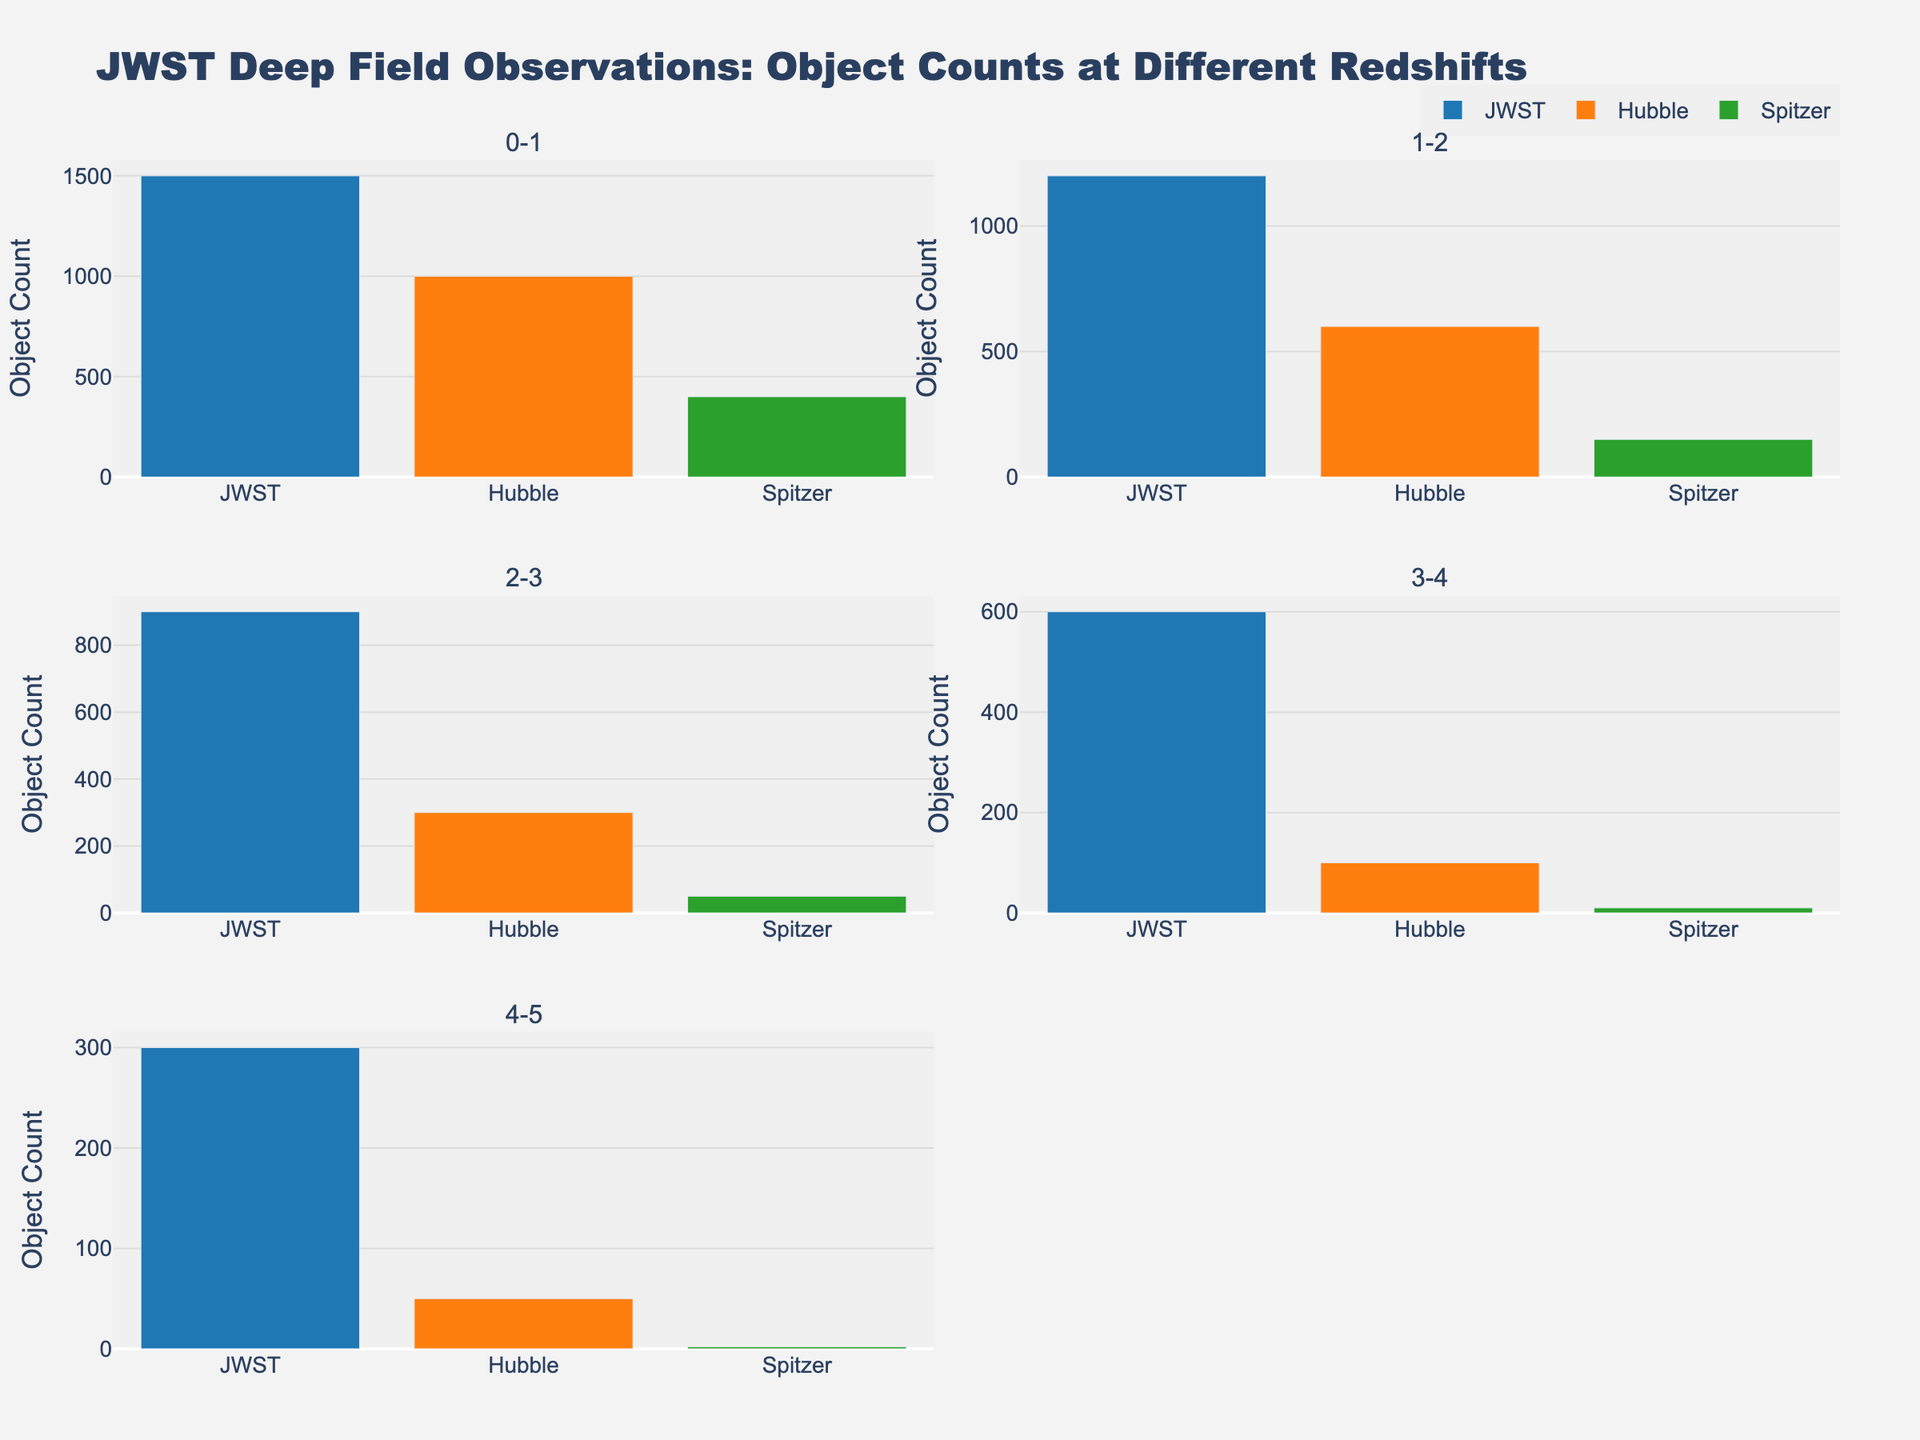What are the main telescopes compared in the subplots? The figure shows JWST, Hubble, and Spitzer as the primary telescopes compared in each subplot. These are indicated by the plot legends and color codes associated with each bar.
Answer: JWST, Hubble, Spitzer What is the title of the entire figure? The title of the figure is displayed at the top of the plot and reads "JWST Deep Field Observations: Object Counts at Different Redshifts".
Answer: JWST Deep Field Observations: Object Counts at Different Redshifts In the redshift range 1-2, how many objects did JWST observe? In the subplot for the redshift range 1-2, the height of the JWST bar indicates the object count. This value is shown as a bar reaching up to 1200.
Answer: 1200 Which telescope observed the highest number of objects in the redshift range 3-4? Comparing the heights of the bars in the 3-4 redshift subplot, the JWST bar is the tallest, indicating it observed the highest number of objects.
Answer: JWST How many more objects did JWST observe than Spitzer in the redshift range 2-3? In the 2-3 redshift range subplot, JWST observed 900 objects and Spitzer observed 300 objects. The difference is 900 - 300.
Answer: 600 What is the sum of the object counts observed by Hubble in redshift ranges 0-1 and 1-2? In the subplot for 0-1 redshift, Hubble observed 1300 objects. In the subplot for 1-2 redshift, Hubble observed 900 objects. The sum is 1300 + 900.
Answer: 2200 Which telescope observed the least number of objects overall across all redshift ranges? By examining the height of the bars across all subplots, Spitzer consistently has the shortest bars, indicating it observed the least number of objects overall.
Answer: Spitzer How does the object count trend for JWST change from redshift 0-1 to 4-5? For JWST, the object counts decrease progressively across the redshift ranges. They start at 1500 in 0-1, decrease to 1200 in 1-2, 900 in 2-3, 600 in 3-4, and 300 in 4-5.
Answer: Decreasing trend 